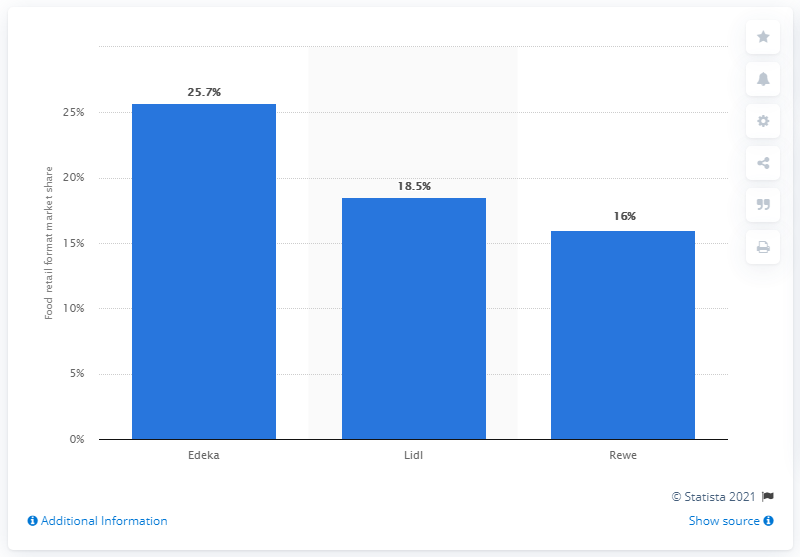List a handful of essential elements in this visual. The second largest grocery retailer in Germany in 2013 was Lidl. 